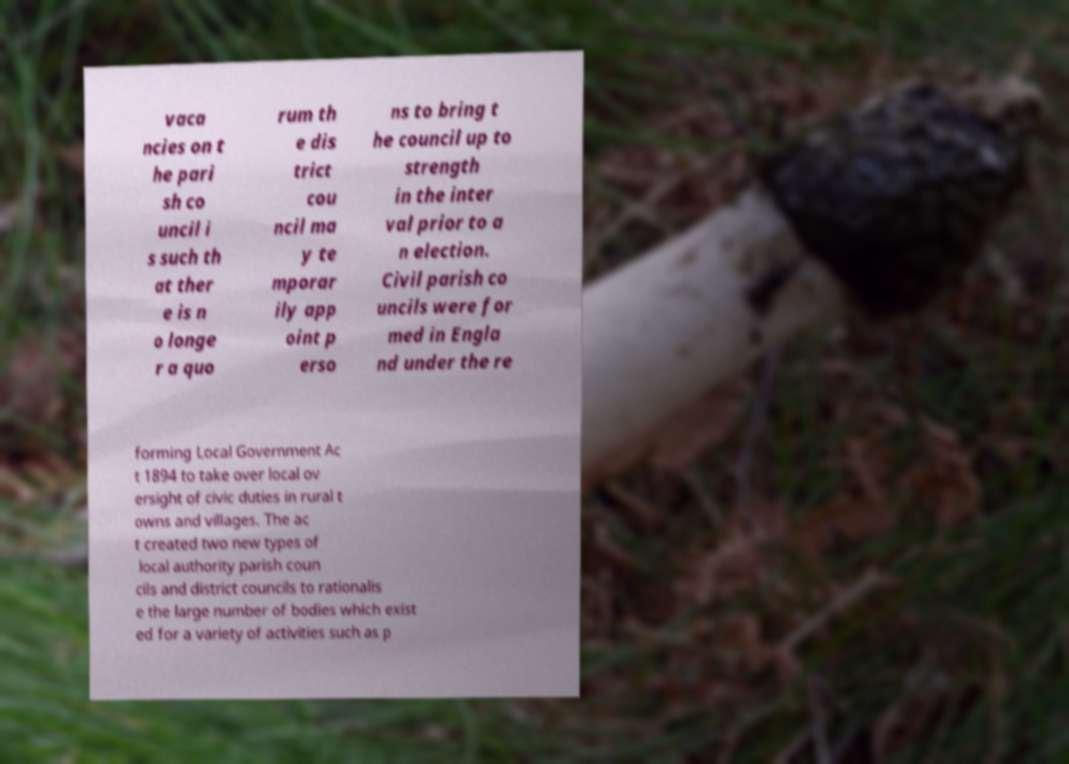Can you read and provide the text displayed in the image?This photo seems to have some interesting text. Can you extract and type it out for me? vaca ncies on t he pari sh co uncil i s such th at ther e is n o longe r a quo rum th e dis trict cou ncil ma y te mporar ily app oint p erso ns to bring t he council up to strength in the inter val prior to a n election. Civil parish co uncils were for med in Engla nd under the re forming Local Government Ac t 1894 to take over local ov ersight of civic duties in rural t owns and villages. The ac t created two new types of local authority parish coun cils and district councils to rationalis e the large number of bodies which exist ed for a variety of activities such as p 